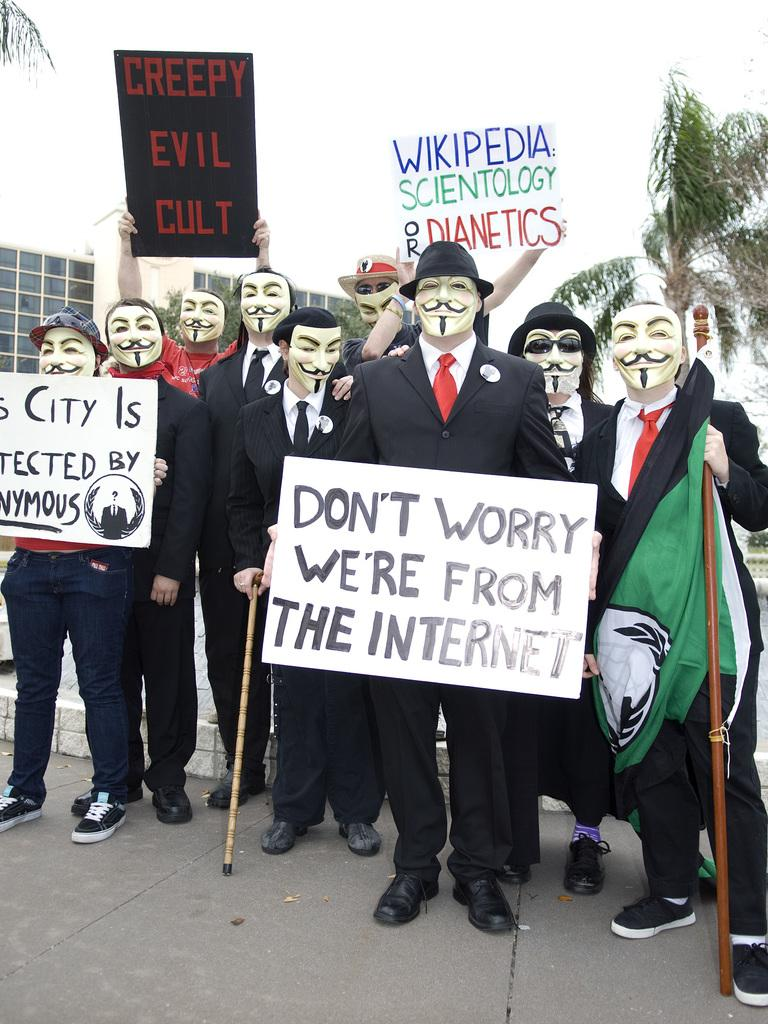Provide a one-sentence caption for the provided image. A group of people in masks are protesting something about the internet. 